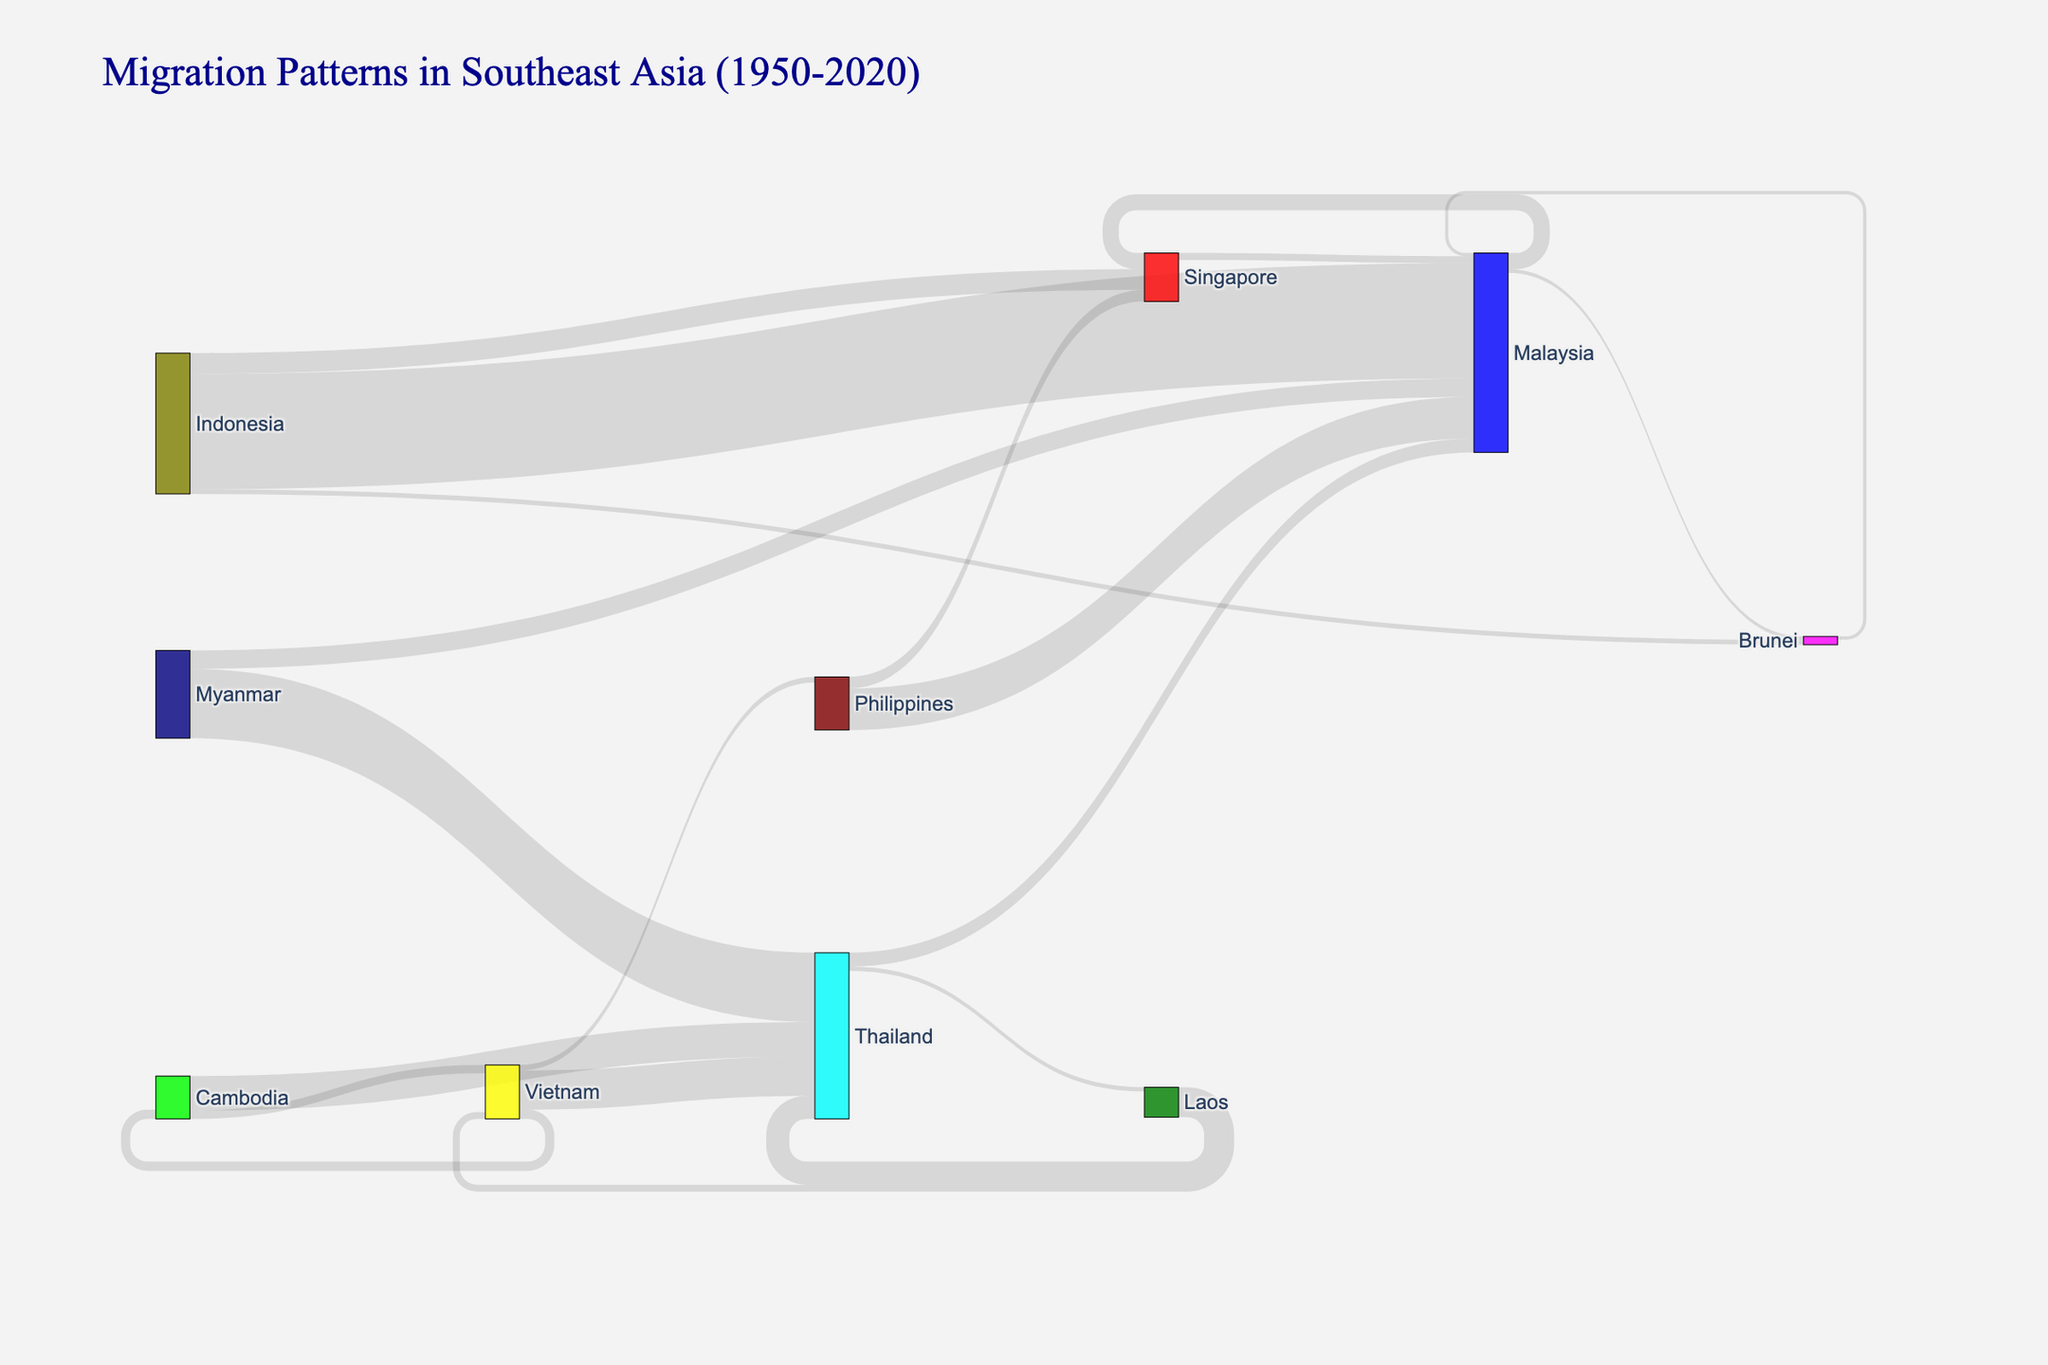What is the title of the Sankey diagram? The title is usually found at the top of the Sankey diagram. In this case, it reads "Migration Patterns in Southeast Asia (1950-2020)."
Answer: Migration Patterns in Southeast Asia (1950-2020) Which two countries have the highest migration value according to the Sankey diagram? To determine the highest migration value, look for the link with the largest value. The link between Indonesia and Malaysia has the highest migration value of 2,500,000.
Answer: Indonesia and Malaysia How many different countries are involved in the migration patterns shown in the Sankey diagram? Count the distinct countries mentioned in the nodes of the Sankey diagram. In this case, there are 10 different countries.
Answer: 10 What is the total migration value from Indonesia to other countries shown in the diagram? Sum up all the migration values originating from Indonesia. The total is 2,500,000 (Malaysia) + 450,000 (Singapore) + 100,000 (Brunei) = 3,050,000.
Answer: 3,050,000 Which country served as a migration destination for the highest number of distinct sources? Count the number of links pointing to each country. Thailand is the destination for the highest number of distinct sources: Vietnam, Myanmar, Cambodia, and Laos (4 sources).
Answer: Thailand Compare the migration values from Philippines to Malaysia and Singapore. Which one is higher and by how much? The migration value from the Philippines to Malaysia is 900,000, while to Singapore is 250,000. The difference is 900,000 - 250,000 = 650,000.
Answer: Malaysia by 650,000 Is the migration value from Cambodia to Thailand greater than from Laos to Vietnam? Compare the two values directly. The migration value from Cambodia to Thailand is 750,000, and from Laos to Vietnam is 150,000. 750,000 is greater than 150,000.
Answer: Yes What is the combined migration value into Malaysia from all sources? Add up the migration values leading to Malaysia: 2,500,000 (Indonesia) + 900,000 (Philippines) + 1,500,000 (Myanmar) + 300,000 (Thailand) + 70,000 (Brunei) + 150,000 (Singapore) = 5,420,000.
Answer: 5,420,000 Which countries have a migration value from Vietnam, and what are those values? Identify the links that originate from Vietnam. The migration values are 850,000 (Thailand), 200,000 (Cambodia), and 120,000 (Philippines).
Answer: Thailand (850,000), Cambodia (200,000), Philippines (120,000) What's the migration value from Malaysia to Brunei and how does it compare to the migration value from Indonesia to Brunei? The migration value from Malaysia to Brunei is 80,000, and from Indonesia to Brunei is 100,000. Indonesia's migration value to Brunei is higher.
Answer: 80,000; Indonesia's value is higher 